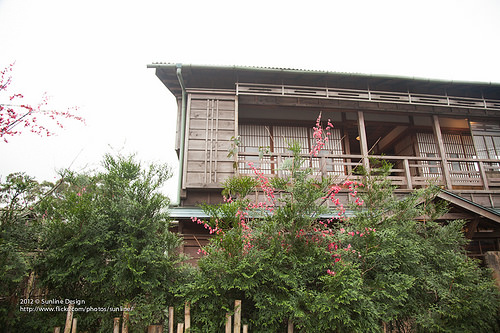<image>
Is there a tree in front of the roof? Yes. The tree is positioned in front of the roof, appearing closer to the camera viewpoint. 